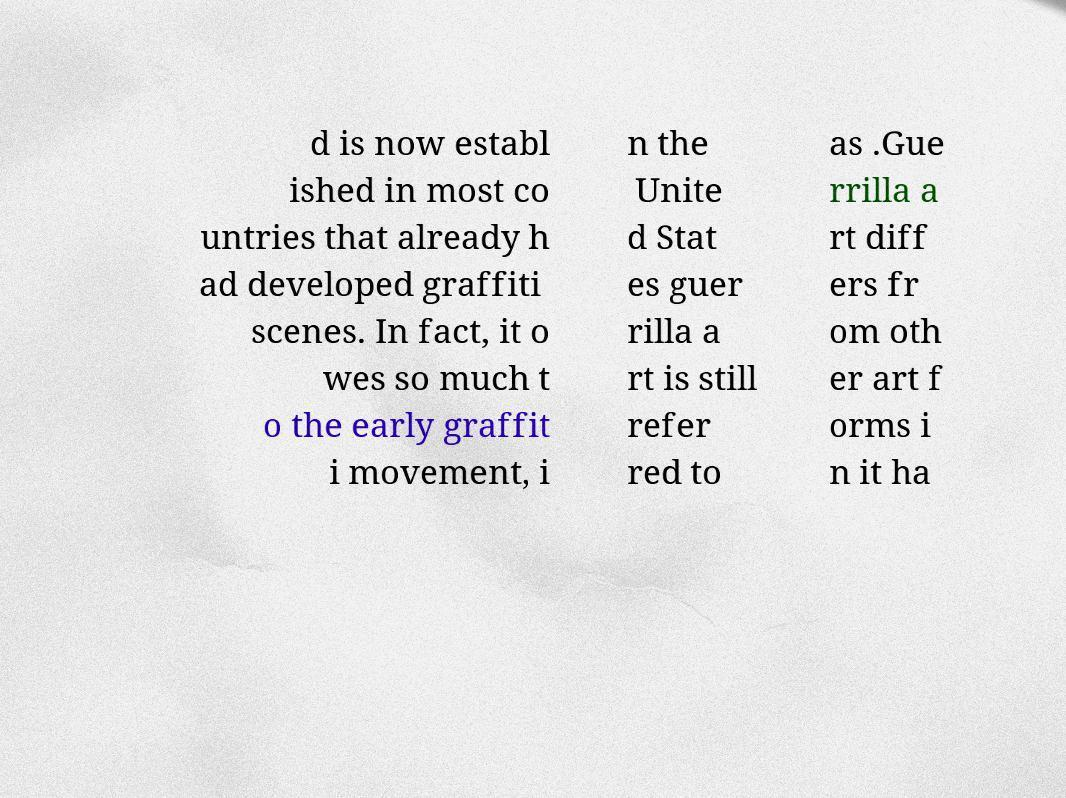Could you assist in decoding the text presented in this image and type it out clearly? d is now establ ished in most co untries that already h ad developed graffiti scenes. In fact, it o wes so much t o the early graffit i movement, i n the Unite d Stat es guer rilla a rt is still refer red to as .Gue rrilla a rt diff ers fr om oth er art f orms i n it ha 